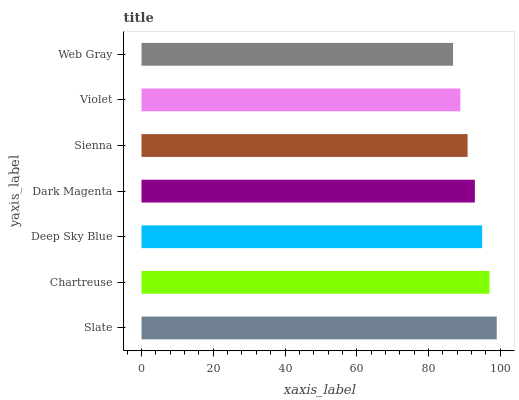Is Web Gray the minimum?
Answer yes or no. Yes. Is Slate the maximum?
Answer yes or no. Yes. Is Chartreuse the minimum?
Answer yes or no. No. Is Chartreuse the maximum?
Answer yes or no. No. Is Slate greater than Chartreuse?
Answer yes or no. Yes. Is Chartreuse less than Slate?
Answer yes or no. Yes. Is Chartreuse greater than Slate?
Answer yes or no. No. Is Slate less than Chartreuse?
Answer yes or no. No. Is Dark Magenta the high median?
Answer yes or no. Yes. Is Dark Magenta the low median?
Answer yes or no. Yes. Is Web Gray the high median?
Answer yes or no. No. Is Slate the low median?
Answer yes or no. No. 